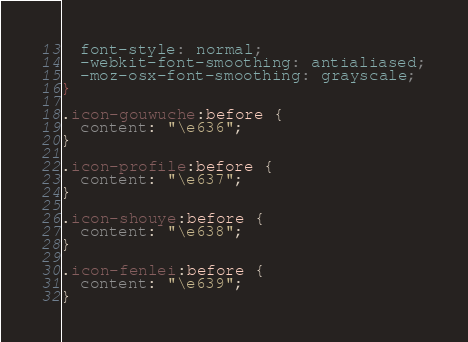<code> <loc_0><loc_0><loc_500><loc_500><_CSS_>  font-style: normal;
  -webkit-font-smoothing: antialiased;
  -moz-osx-font-smoothing: grayscale;
}

.icon-gouwuche:before {
  content: "\e636";
}

.icon-profile:before {
  content: "\e637";
}

.icon-shouye:before {
  content: "\e638";
}

.icon-fenlei:before {
  content: "\e639";
}

</code> 